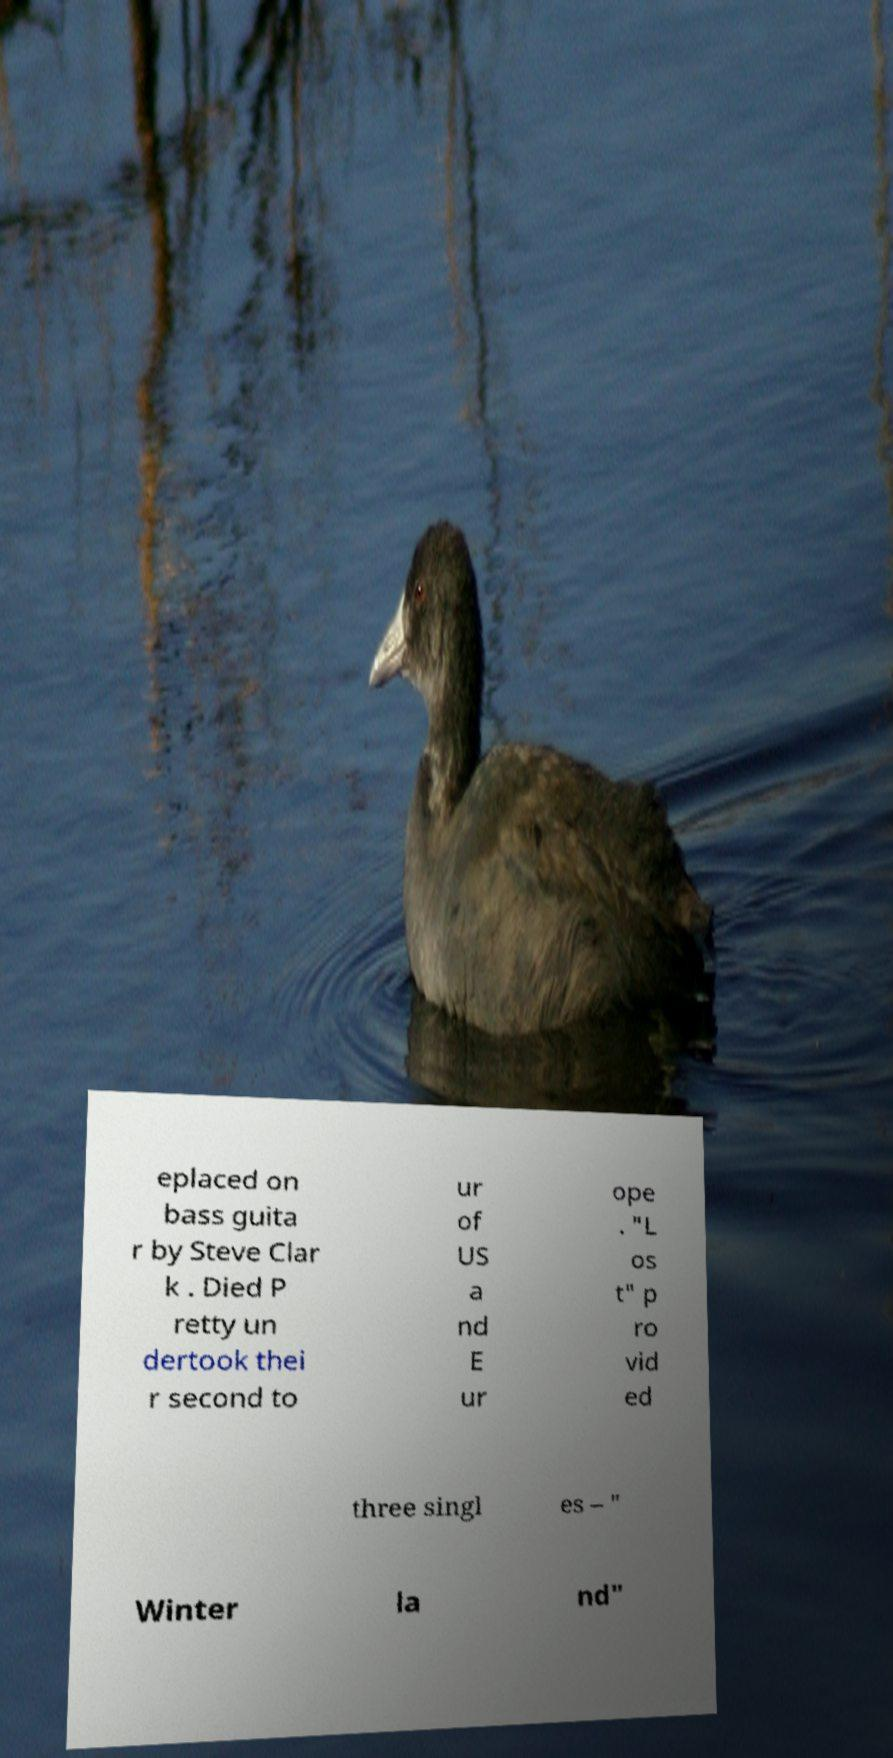I need the written content from this picture converted into text. Can you do that? eplaced on bass guita r by Steve Clar k . Died P retty un dertook thei r second to ur of US a nd E ur ope . "L os t" p ro vid ed three singl es – " Winter la nd" 